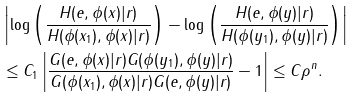<formula> <loc_0><loc_0><loc_500><loc_500>& \left | \log \left ( \frac { H ( e , \phi ( x ) | r ) } { H ( \phi ( x _ { 1 } ) , \phi ( x ) | r ) } \right ) - \log \left ( \frac { H ( e , \phi ( y ) | r ) } { H ( \phi ( y _ { 1 } ) , \phi ( y ) | r ) } \right ) \right | \\ & \leq C _ { 1 } \left | \frac { G ( e , \phi ( x ) | r ) G ( \phi ( y _ { 1 } ) , \phi ( y ) | r ) } { G ( \phi ( x _ { 1 } ) , \phi ( x ) | r ) G ( e , \phi ( y ) | r ) } - 1 \right | \leq C \rho ^ { n } .</formula> 